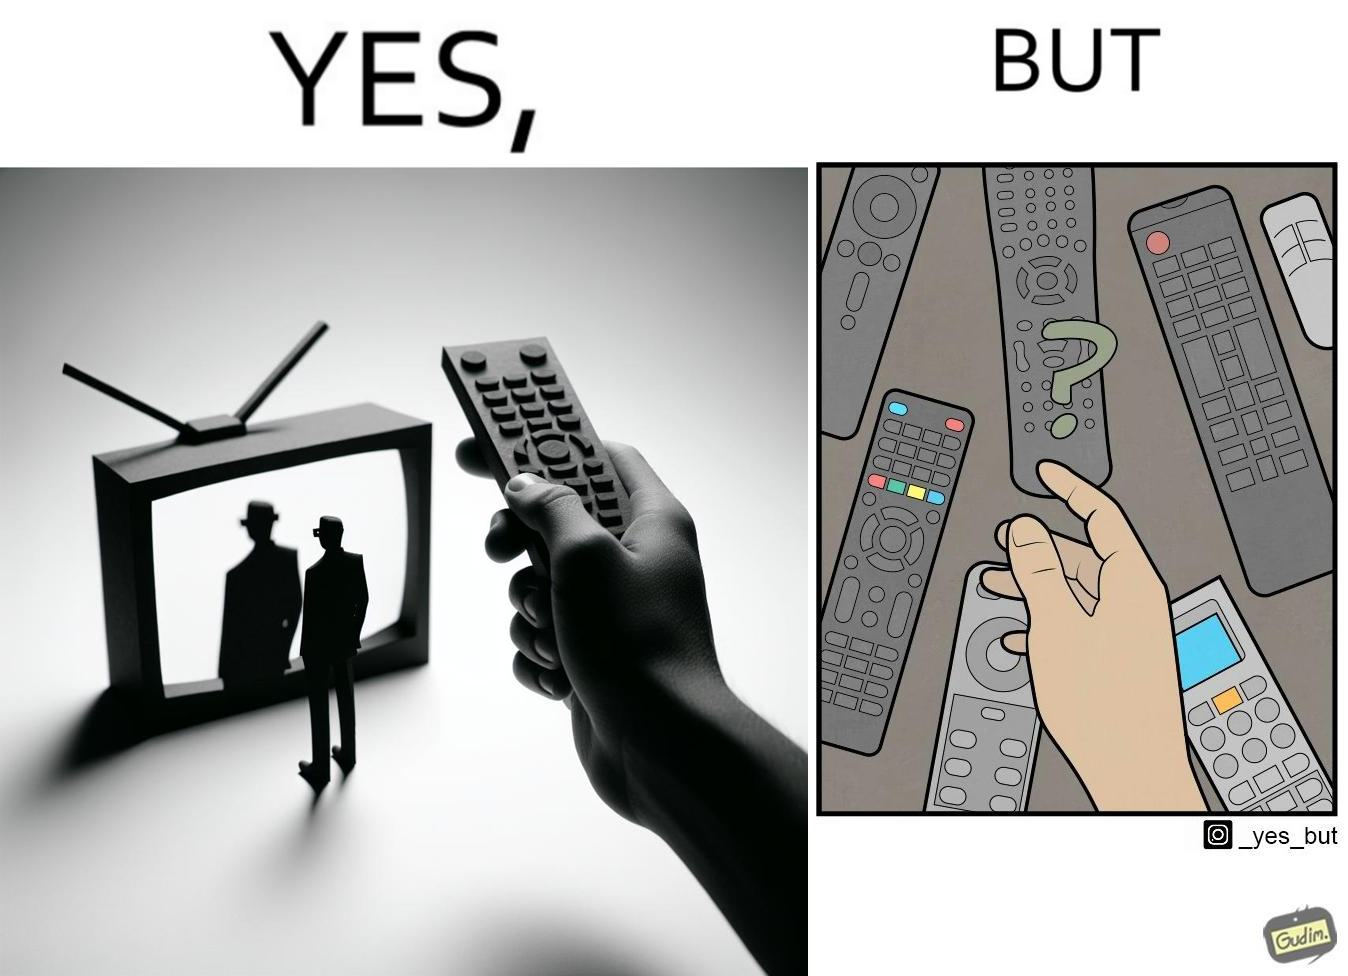What is shown in this image? The images are funny since they show how even though TV remotes are supposed to make operating TVs easier, having multiple similar looking remotes  for everything only makes it more difficult for the user to use the right one 